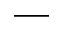<formula> <loc_0><loc_0><loc_500><loc_500>\text  underscore</formula> 